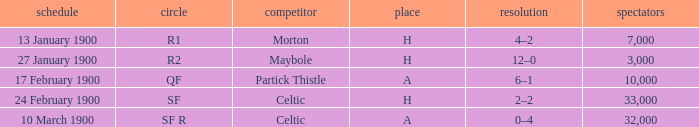What round did the celtic played away on 24 february 1900? SF. 